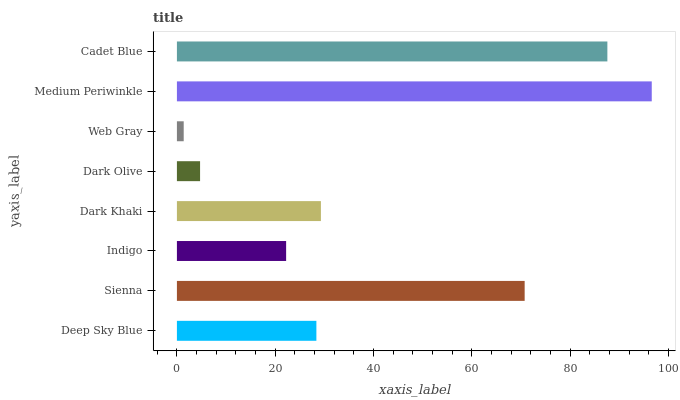Is Web Gray the minimum?
Answer yes or no. Yes. Is Medium Periwinkle the maximum?
Answer yes or no. Yes. Is Sienna the minimum?
Answer yes or no. No. Is Sienna the maximum?
Answer yes or no. No. Is Sienna greater than Deep Sky Blue?
Answer yes or no. Yes. Is Deep Sky Blue less than Sienna?
Answer yes or no. Yes. Is Deep Sky Blue greater than Sienna?
Answer yes or no. No. Is Sienna less than Deep Sky Blue?
Answer yes or no. No. Is Dark Khaki the high median?
Answer yes or no. Yes. Is Deep Sky Blue the low median?
Answer yes or no. Yes. Is Cadet Blue the high median?
Answer yes or no. No. Is Web Gray the low median?
Answer yes or no. No. 